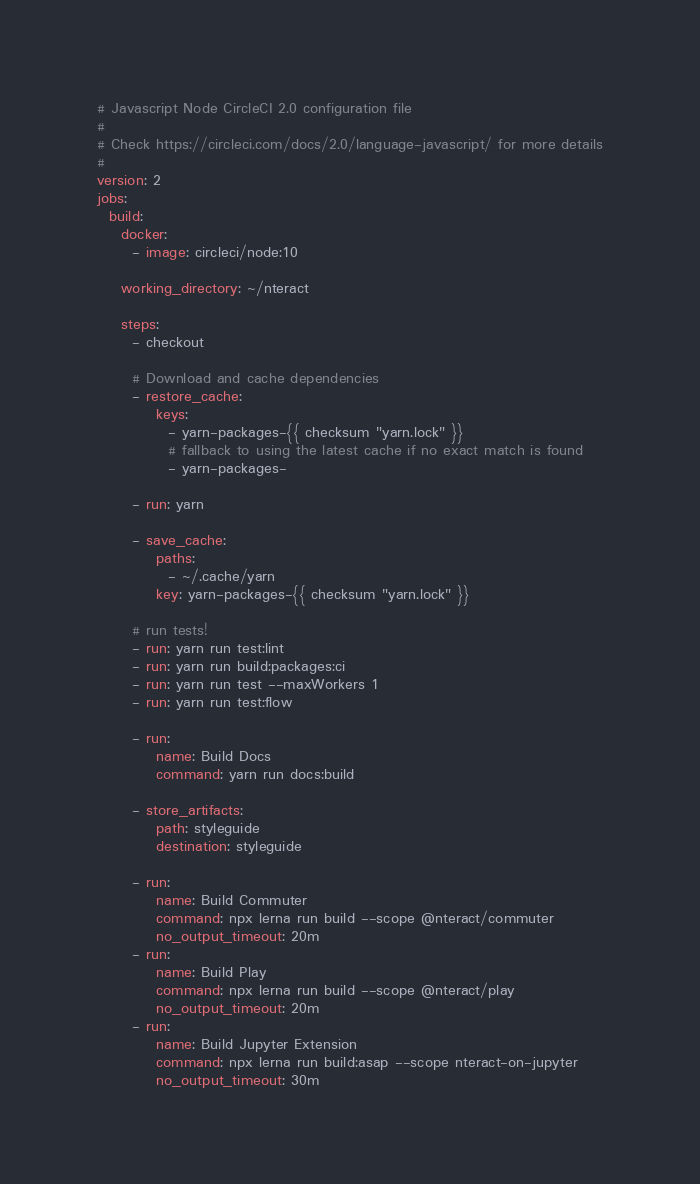Convert code to text. <code><loc_0><loc_0><loc_500><loc_500><_YAML_># Javascript Node CircleCI 2.0 configuration file
#
# Check https://circleci.com/docs/2.0/language-javascript/ for more details
#
version: 2
jobs:
  build:
    docker:
      - image: circleci/node:10

    working_directory: ~/nteract

    steps:
      - checkout

      # Download and cache dependencies
      - restore_cache:
          keys:
            - yarn-packages-{{ checksum "yarn.lock" }}
            # fallback to using the latest cache if no exact match is found
            - yarn-packages-

      - run: yarn

      - save_cache:
          paths:
            - ~/.cache/yarn
          key: yarn-packages-{{ checksum "yarn.lock" }}

      # run tests!
      - run: yarn run test:lint
      - run: yarn run build:packages:ci
      - run: yarn run test --maxWorkers 1
      - run: yarn run test:flow

      - run:
          name: Build Docs
          command: yarn run docs:build

      - store_artifacts:
          path: styleguide
          destination: styleguide

      - run:
          name: Build Commuter
          command: npx lerna run build --scope @nteract/commuter
          no_output_timeout: 20m
      - run:
          name: Build Play
          command: npx lerna run build --scope @nteract/play
          no_output_timeout: 20m
      - run:
          name: Build Jupyter Extension
          command: npx lerna run build:asap --scope nteract-on-jupyter
          no_output_timeout: 30m
</code> 